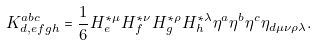Convert formula to latex. <formula><loc_0><loc_0><loc_500><loc_500>K _ { d , e f g h } ^ { a b c } = \frac { 1 } { 6 } H _ { e } ^ { \ast \mu } H _ { f } ^ { \ast \nu } H _ { g } ^ { \ast \rho } H _ { h } ^ { \ast \lambda } \eta ^ { a } \eta ^ { b } \eta ^ { c } \eta _ { d \mu \nu \rho \lambda } .</formula> 